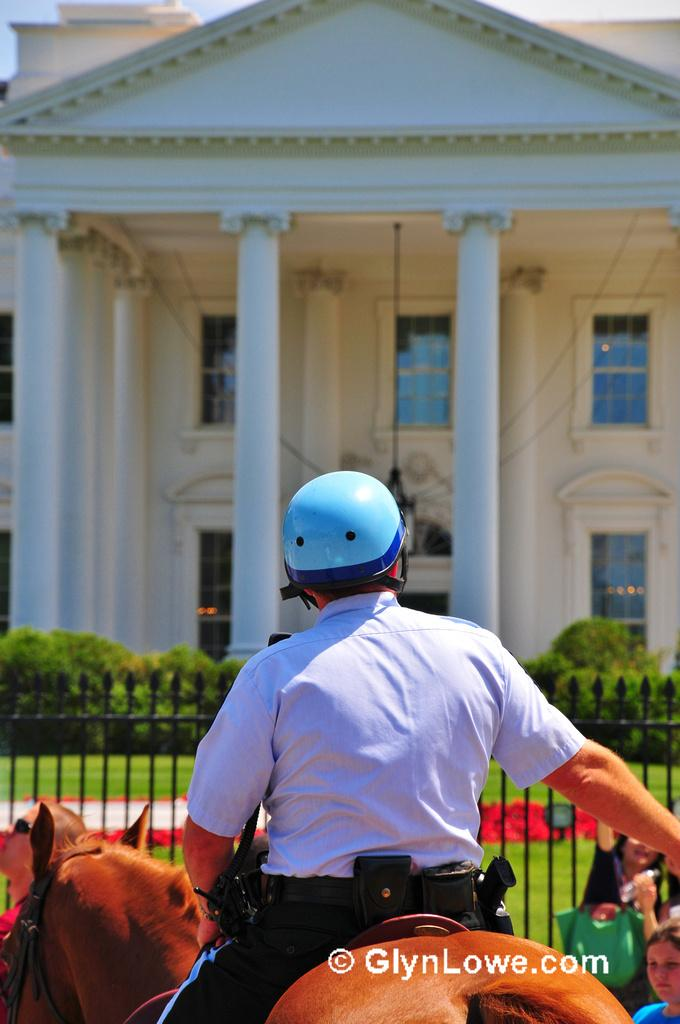What is the man in the image doing? The man is sitting on a horse. What is the man wearing on his head? The man is wearing a blue helmet. What can be seen in the background of the image? There is a fence, plants, grass, and a white house building with white pillars and windows in the distance. Can you describe the fence in the image? The fence is black in color. What type of engine can be seen powering the horse in the image? There is no engine present in the image; the horse is being ridden by the man. What color is the button on the man's shirt in the image? There is no button mentioned in the image, and the man's shirt is not described in detail. 